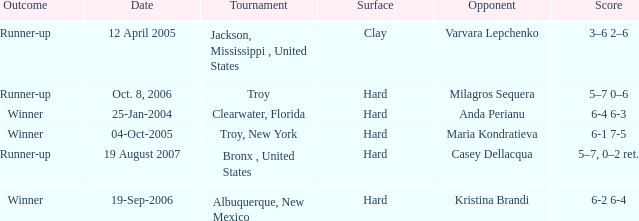What is the final score of the tournament played in Clearwater, Florida? 6-4 6-3. 